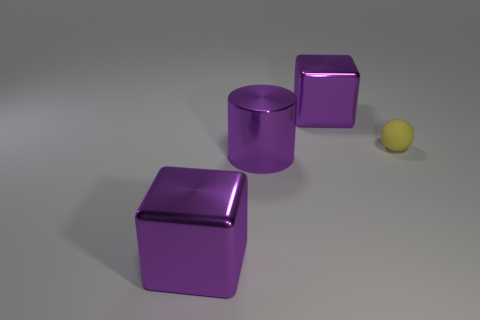What insights can you infer about the lighting and environment in which these objects are placed? The objects are situated in an environment with diffuse lighting, as indicated by the soft shadows cast on the ground, suggesting an overcast sky or artificial lighting without harsh direct light. The lack of any distinct background elements and the uniform floor hint at a controlled setting, such as a studio where the primary focus is on the objects themselves. 